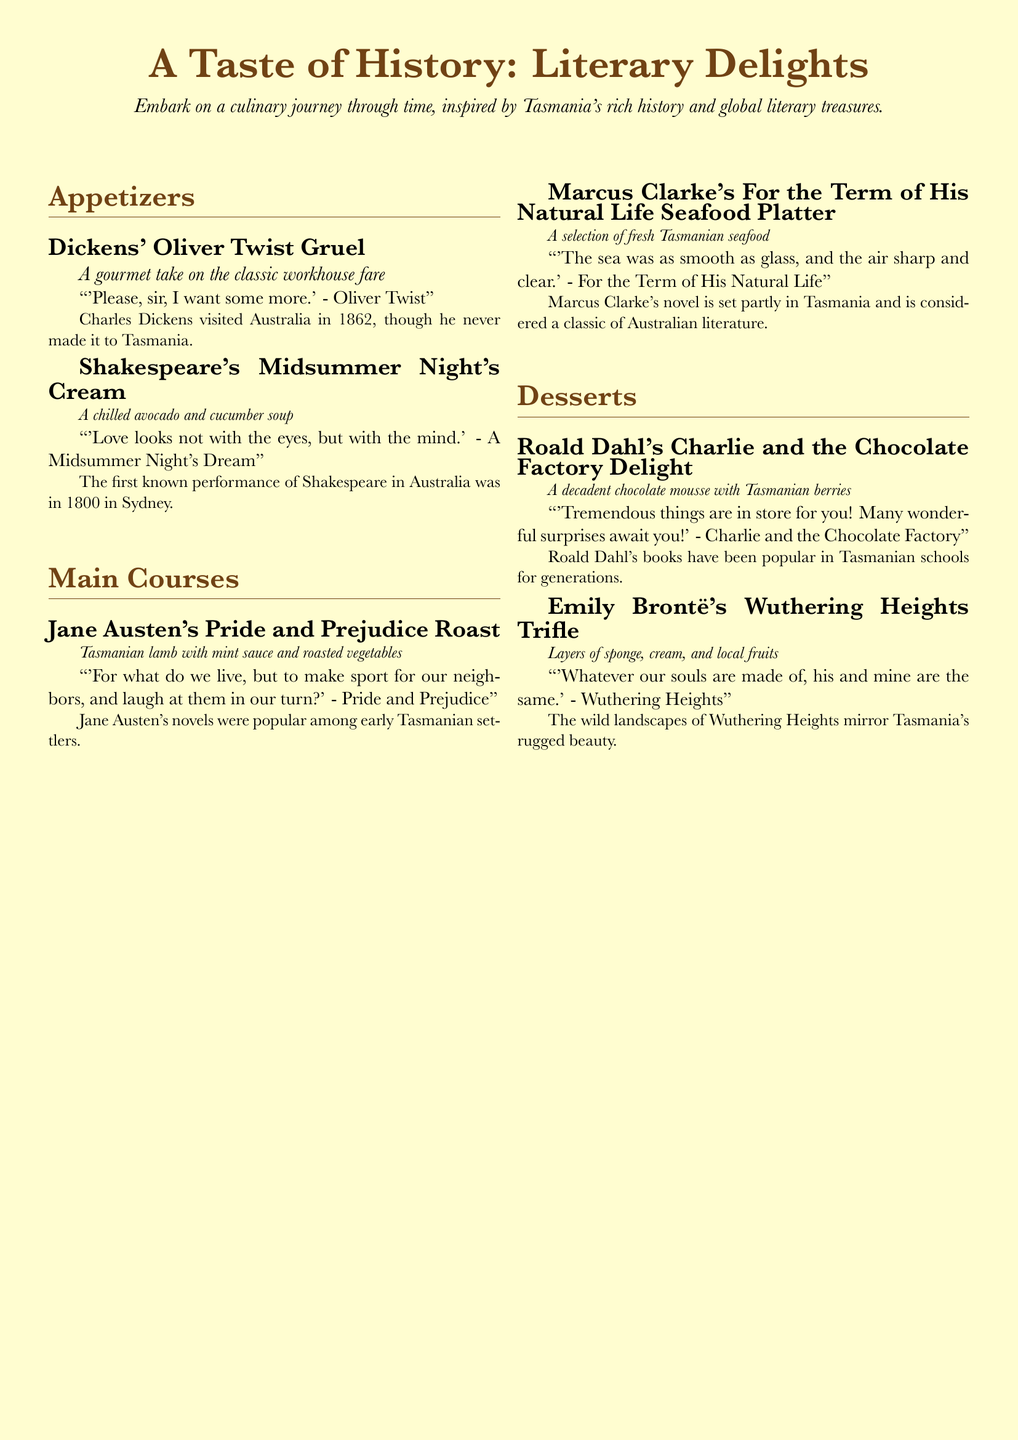What is the theme of the menu? The theme of the menu is inspired by Tasmania's history and global literary treasures.
Answer: Tasmania's history and global literary treasures What dish is named after a Dickens work? The dish named after a Dickens work is "Oliver Twist Gruel."
Answer: Oliver Twist Gruel Which ingredient is featured in the "Pride and Prejudice Roast"? The "Pride and Prejudice Roast" features Tasmanian lamb.
Answer: Tasmanian lamb What dessert is based on a Roald Dahl book? The dessert based on a Roald Dahl book is "Charlie and the Chocolate Factory Delight."
Answer: Charlie and the Chocolate Factory Delight What does the quote from "Wuthering Heights" express? The quote from "Wuthering Heights" expresses a deep connection between souls.
Answer: A deep connection between souls What ingredient is common in "Midsummer Night's Cream"? "Midsummer Night's Cream" commonly includes avocado and cucumber.
Answer: Avocado and cucumber Which author is associated with Tasmania in this menu? Marcus Clarke is associated with Tasmania in this menu.
Answer: Marcus Clarke How is the "For the Term of His Natural Life" seafood described? The seafood is described as a selection of fresh Tasmanian seafood.
Answer: A selection of fresh Tasmanian seafood What type of soup is served as "Midsummer Night's Cream"? The soup served as "Midsummer Night's Cream" is a chilled soup.
Answer: Chilled soup Which quote accompanies the "Charlie and the Chocolate Factory Delight"? The quote accompanying it is "Tremendous things are in store for you!"
Answer: "Tremendous things are in store for you!" 